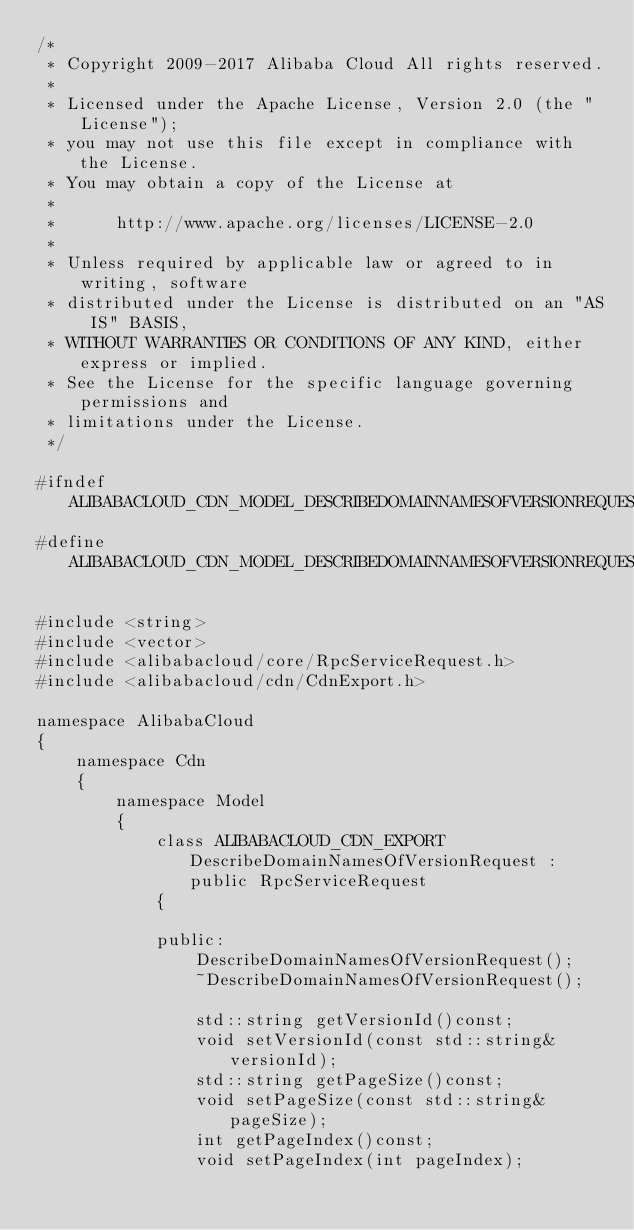<code> <loc_0><loc_0><loc_500><loc_500><_C_>/*
 * Copyright 2009-2017 Alibaba Cloud All rights reserved.
 * 
 * Licensed under the Apache License, Version 2.0 (the "License");
 * you may not use this file except in compliance with the License.
 * You may obtain a copy of the License at
 * 
 *      http://www.apache.org/licenses/LICENSE-2.0
 * 
 * Unless required by applicable law or agreed to in writing, software
 * distributed under the License is distributed on an "AS IS" BASIS,
 * WITHOUT WARRANTIES OR CONDITIONS OF ANY KIND, either express or implied.
 * See the License for the specific language governing permissions and
 * limitations under the License.
 */

#ifndef ALIBABACLOUD_CDN_MODEL_DESCRIBEDOMAINNAMESOFVERSIONREQUEST_H_
#define ALIBABACLOUD_CDN_MODEL_DESCRIBEDOMAINNAMESOFVERSIONREQUEST_H_

#include <string>
#include <vector>
#include <alibabacloud/core/RpcServiceRequest.h>
#include <alibabacloud/cdn/CdnExport.h>

namespace AlibabaCloud
{
	namespace Cdn
	{
		namespace Model
		{
			class ALIBABACLOUD_CDN_EXPORT DescribeDomainNamesOfVersionRequest : public RpcServiceRequest
			{

			public:
				DescribeDomainNamesOfVersionRequest();
				~DescribeDomainNamesOfVersionRequest();

				std::string getVersionId()const;
				void setVersionId(const std::string& versionId);
				std::string getPageSize()const;
				void setPageSize(const std::string& pageSize);
				int getPageIndex()const;
				void setPageIndex(int pageIndex);</code> 